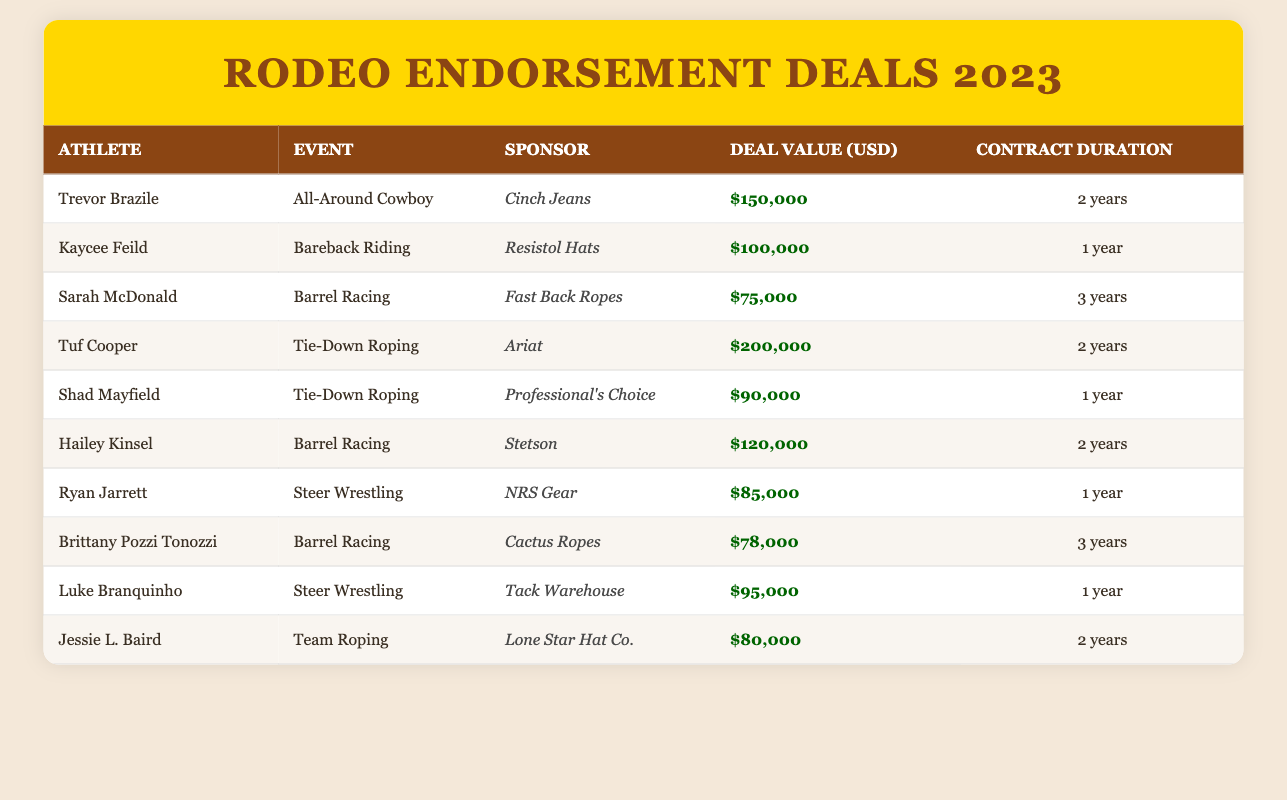What is the endorsement deal value for Tuf Cooper? Tuf Cooper has an endorsement deal value listed in the table, which is $200,000.
Answer: $200,000 Which athlete has the longest contract duration? Sarah McDonald and Brittany Pozzi Tonozzi both have endorsement deals with a contract duration of 3 years, which is the longest listed in the table.
Answer: Sarah McDonald and Brittany Pozzi Tonozzi What is the total deal value of all endorsement deals combined? The total deal value is calculated by adding all deal values together: 150000 + 100000 + 75000 + 200000 + 90000 + 120000 + 85000 + 78000 + 95000 + 80000 = 1,190,000.
Answer: $1,190,000 Is Hailey Kinsel sponsored by Stetson? The table indicates that Hailey Kinsel's sponsor is indeed Stetson, confirming the fact.
Answer: Yes What is the average endorsement deal value for the barrel racing athletes? The endorsement deal values for the barrel racing athletes are $75,000, $120,000, and $78,000. Summing these gives $273,000, and dividing by 3 (the number of athletes) results in an average of $91,000.
Answer: $91,000 Which event type has the highest single endorsement deal value? The table shows that Tuf Cooper's endorsement deal for Tie-Down Roping is the highest at $200,000. Thus, Tie-Down Roping has the highest single endorsement deal value.
Answer: Tie-Down Roping How many athletes have endorsements for 1 year? Four athletes have contracts lasting 1 year: Kaycee Feild, Shad Mayfield, Ryan Jarrett, and Luke Branquinho. Counting them gives a total of 4 athletes.
Answer: 4 What is the total deal value for the athletes in barrel racing events? The total for barrel racing, which includes Sarah McDonald ($75,000), Hailey Kinsel ($120,000), and Brittany Pozzi Tonozzi ($78,000), is calculated as: 75000 + 120000 + 78000 = 273000.
Answer: $273,000 